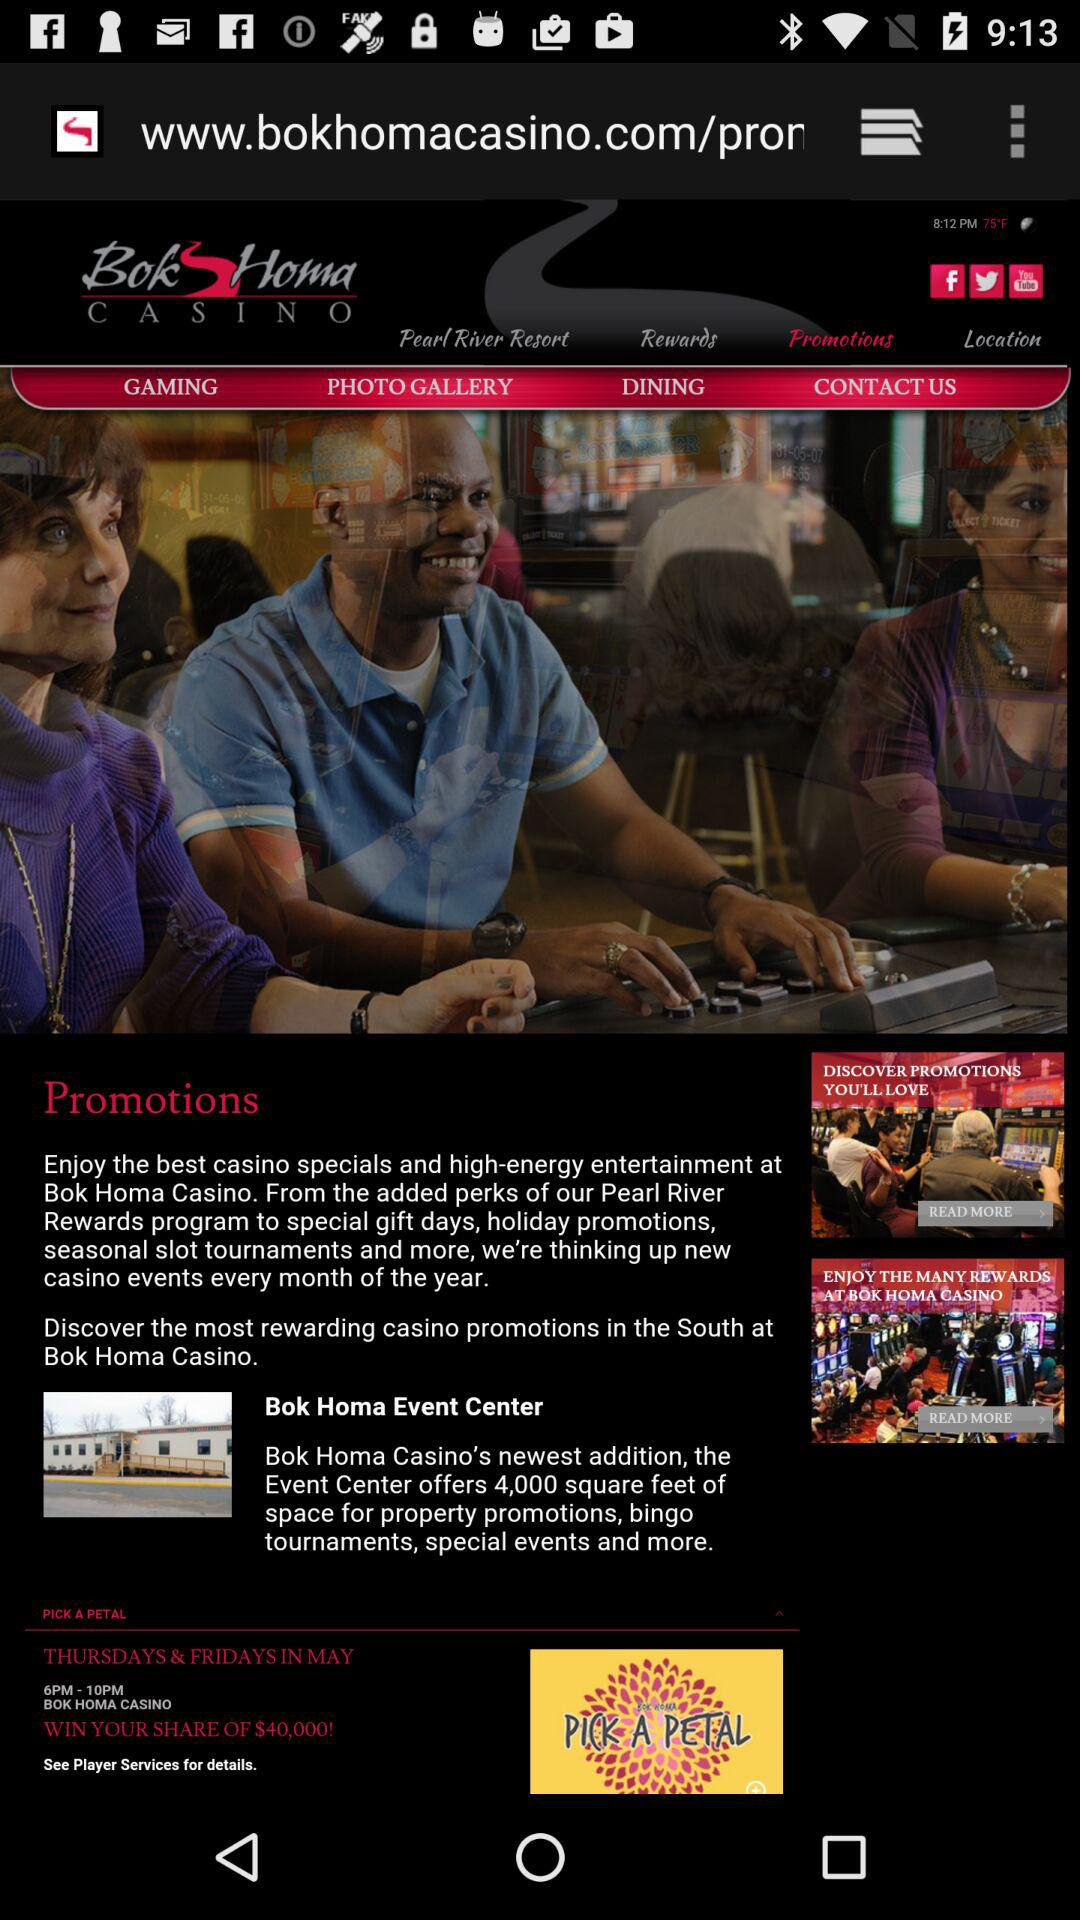What is the winning amount in "PICK A PETAL"? The winning amount in "PICK A PETAL" is $40,000. 